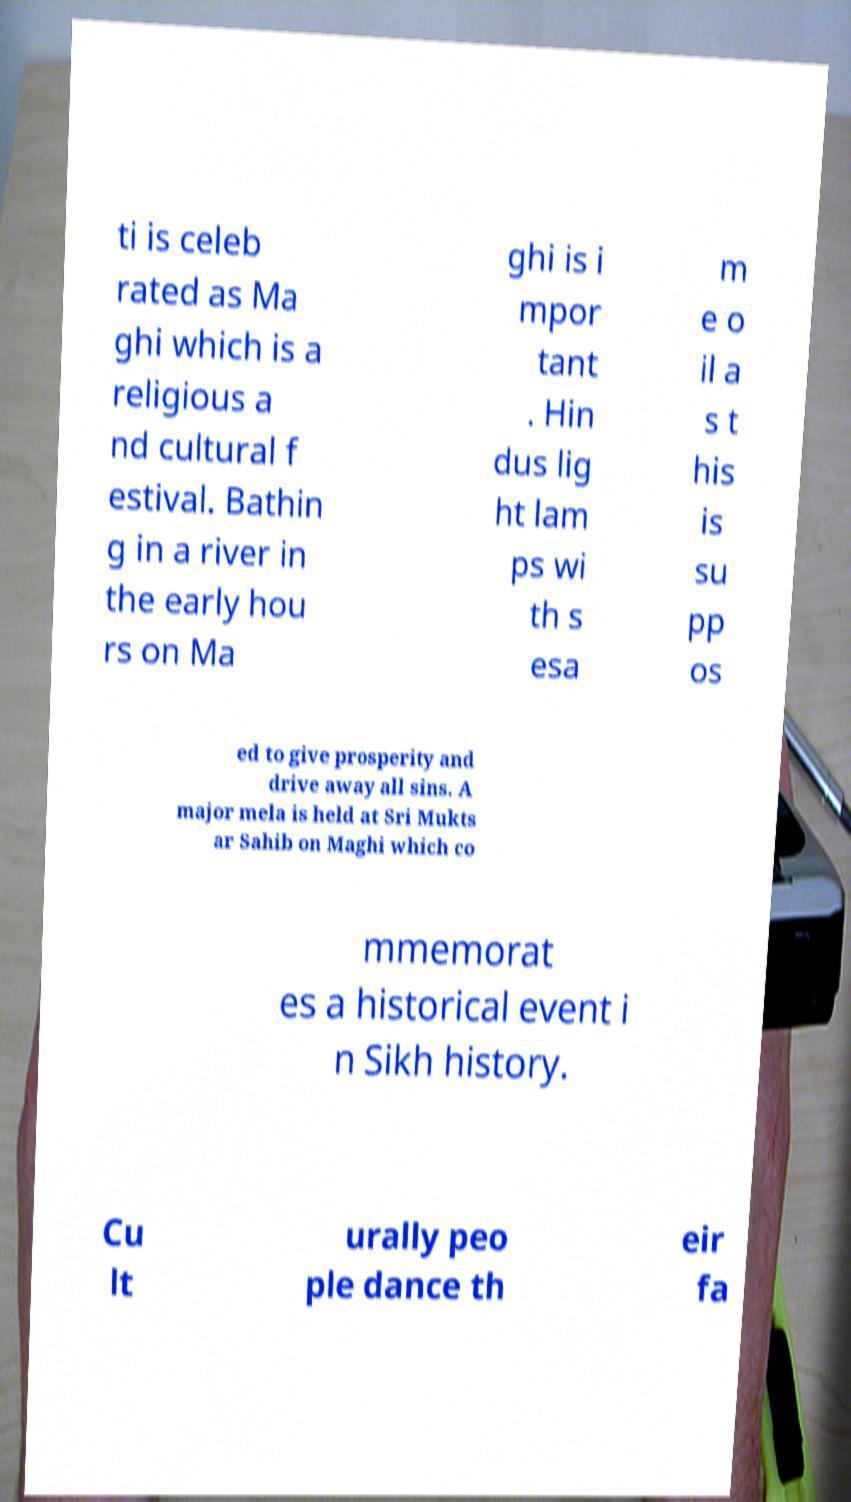Can you read and provide the text displayed in the image?This photo seems to have some interesting text. Can you extract and type it out for me? ti is celeb rated as Ma ghi which is a religious a nd cultural f estival. Bathin g in a river in the early hou rs on Ma ghi is i mpor tant . Hin dus lig ht lam ps wi th s esa m e o il a s t his is su pp os ed to give prosperity and drive away all sins. A major mela is held at Sri Mukts ar Sahib on Maghi which co mmemorat es a historical event i n Sikh history. Cu lt urally peo ple dance th eir fa 